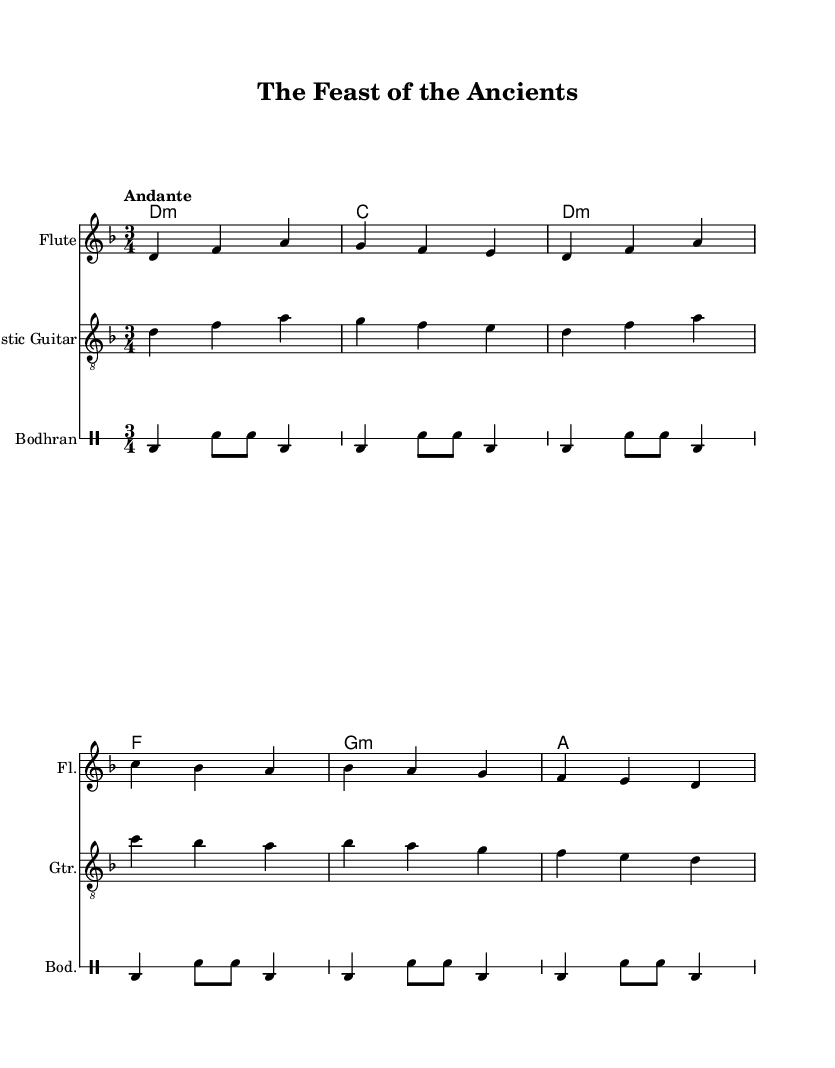What is the key signature of this music? The key signature is indicated by the two flats in the beginning of the sheet music. These flats correspond to B flat and E flat, which signifies that the piece is in D minor.
Answer: D minor What is the time signature of this piece? The time signature is displayed at the beginning of the score right after the key signature. It shows "3/4," which indicates a waltz feel, with three beats per measure.
Answer: 3/4 What is the tempo marking for the piece? The tempo marking is provided as "Andante," which suggests a moderately slow tempo. This marking gives performers guidance on the speed of the piece.
Answer: Andante How many measures are in the melody? To find the number of measures in the melody, one must count the vertical bar lines that denote the end of each measure. In this section, there are six measures.
Answer: Six What instruments are featured in this score? The score indicates three different instruments: Flute, Acoustic Guitar, and Bodhran. Each instrument is presented separately, allowing for a clear understanding of the arrangement.
Answer: Flute, Acoustic Guitar, Bodhran What type of music does this piece represent? The lyrics and the title clearly indicate that this piece is a folk ballad, which is evidenced by its narrative style and thematic focus on ancient food rituals.
Answer: Folk ballad 